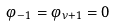<formula> <loc_0><loc_0><loc_500><loc_500>\varphi _ { - 1 } = \varphi _ { \nu + 1 } = 0</formula> 